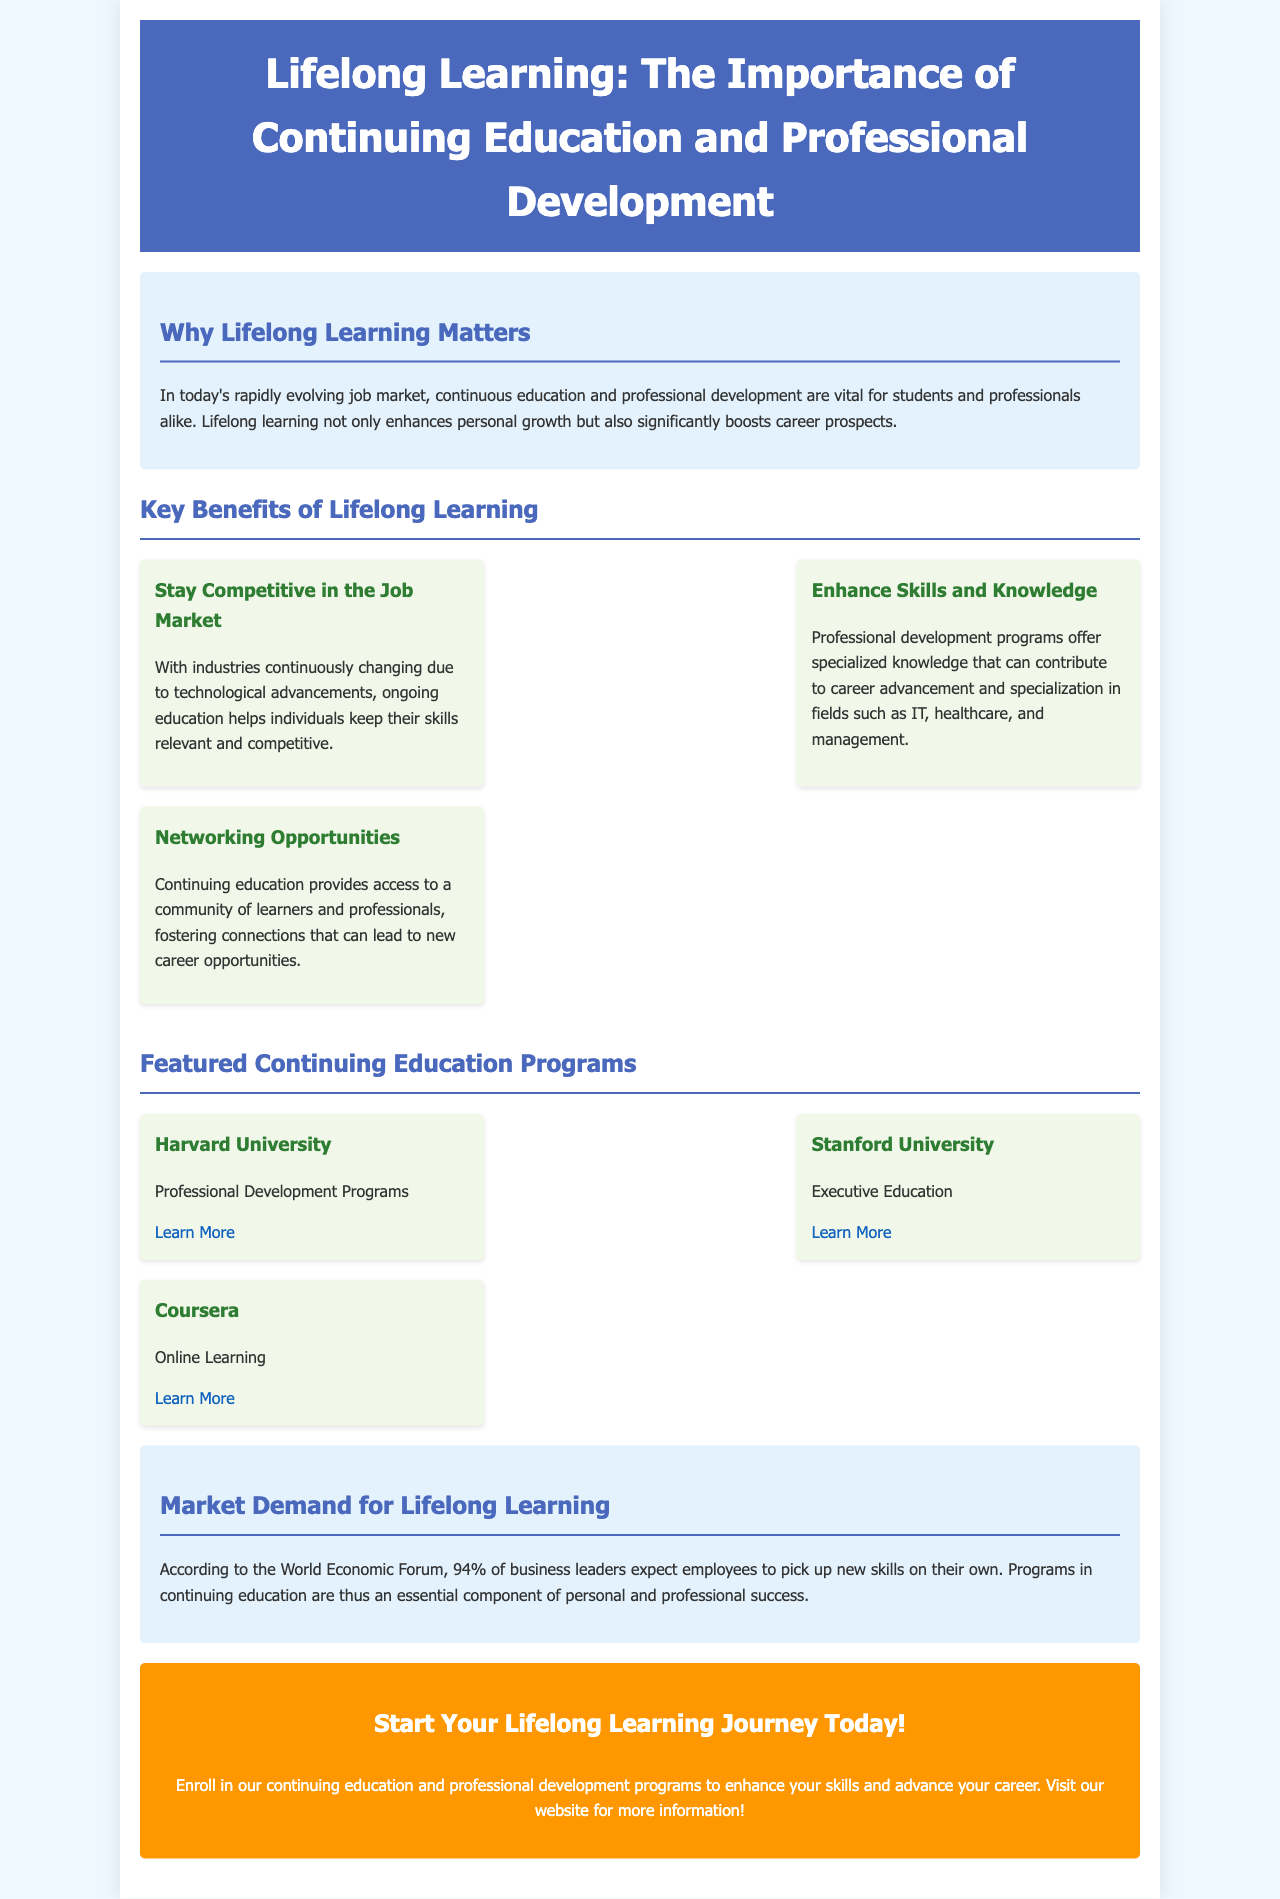what is the main topic of the brochure? The main topic is focused on the importance of lifelong learning and professional development programs.
Answer: Lifelong Learning who published the professional development programs mentioned in the brochure? The brochure lists three institutions that offer professional development programs: Harvard University, Stanford University, and Coursera.
Answer: Harvard University, Stanford University, Coursera what percentage of business leaders expect employees to learn new skills independently? The document states that 94% of business leaders expect employees to pick up new skills on their own.
Answer: 94% what is one benefit of networking through continuing education? Networking opportunities can foster connections that may lead to new career opportunities.
Answer: New career opportunities what does ongoing education help individuals maintain? Ongoing education helps individuals maintain relevant and competitive skills in the job market.
Answer: Relevant and competitive skills what type of learning does Coursera provide? Coursera is associated with online learning programs according to the brochure.
Answer: Online Learning which section provides statistics about market demand for lifelong learning? The market demand statistics are provided in the section specifically titled "Market Demand for Lifelong Learning."
Answer: Market Demand for Lifelong Learning what is the call to action in the brochure? The call to action encourages readers to enroll in continuing education and professional development programs.
Answer: Enroll in programs 